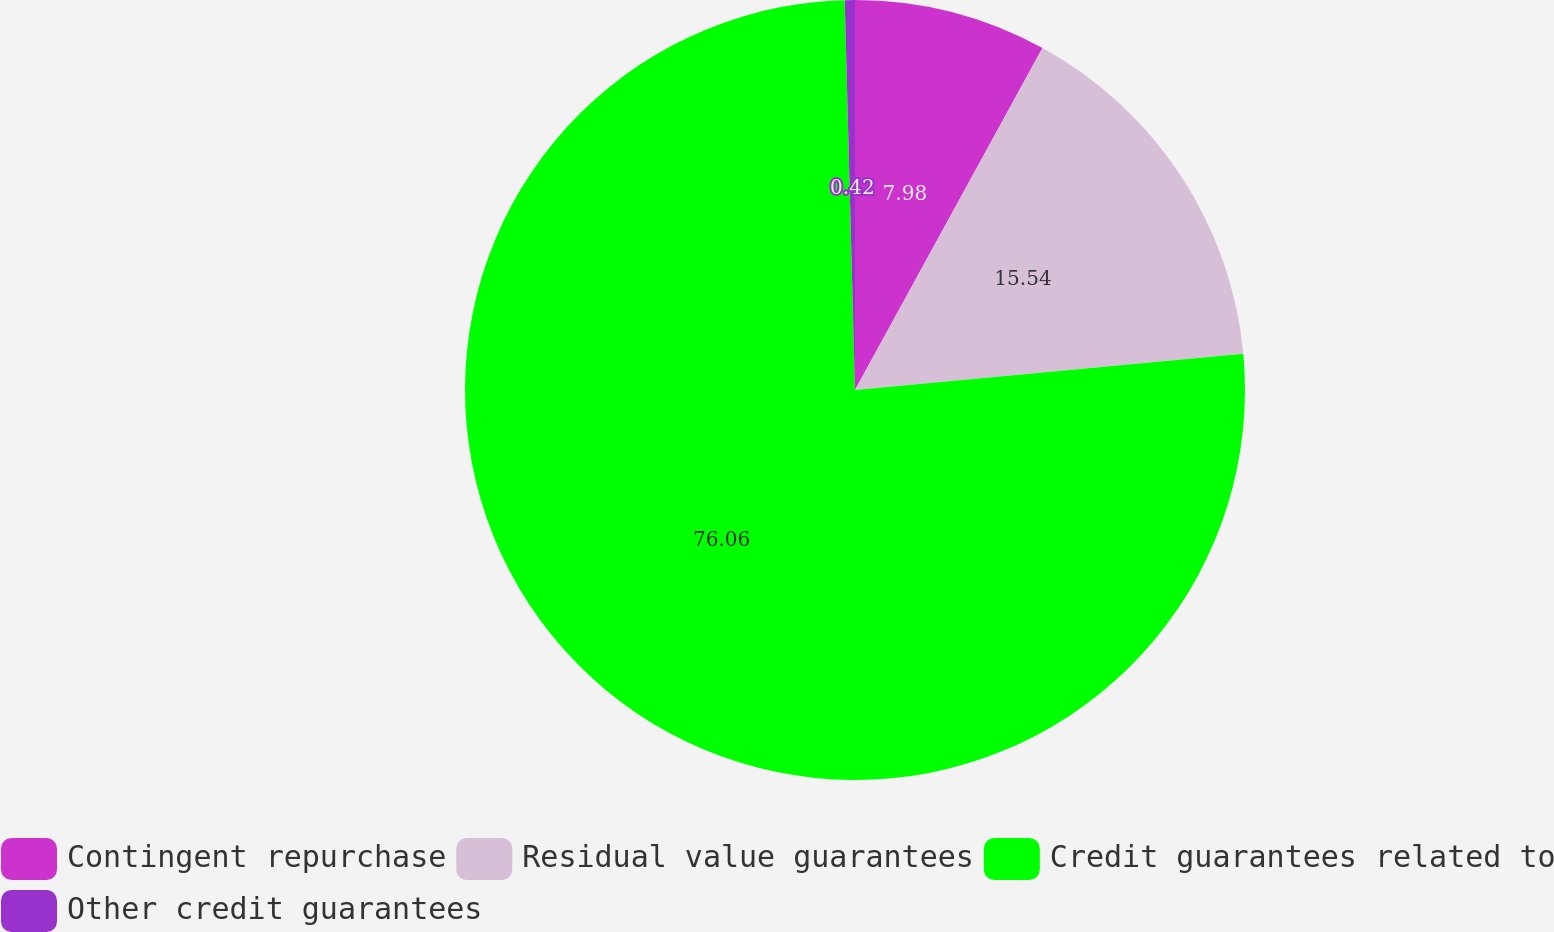Convert chart to OTSL. <chart><loc_0><loc_0><loc_500><loc_500><pie_chart><fcel>Contingent repurchase<fcel>Residual value guarantees<fcel>Credit guarantees related to<fcel>Other credit guarantees<nl><fcel>7.98%<fcel>15.54%<fcel>76.06%<fcel>0.42%<nl></chart> 